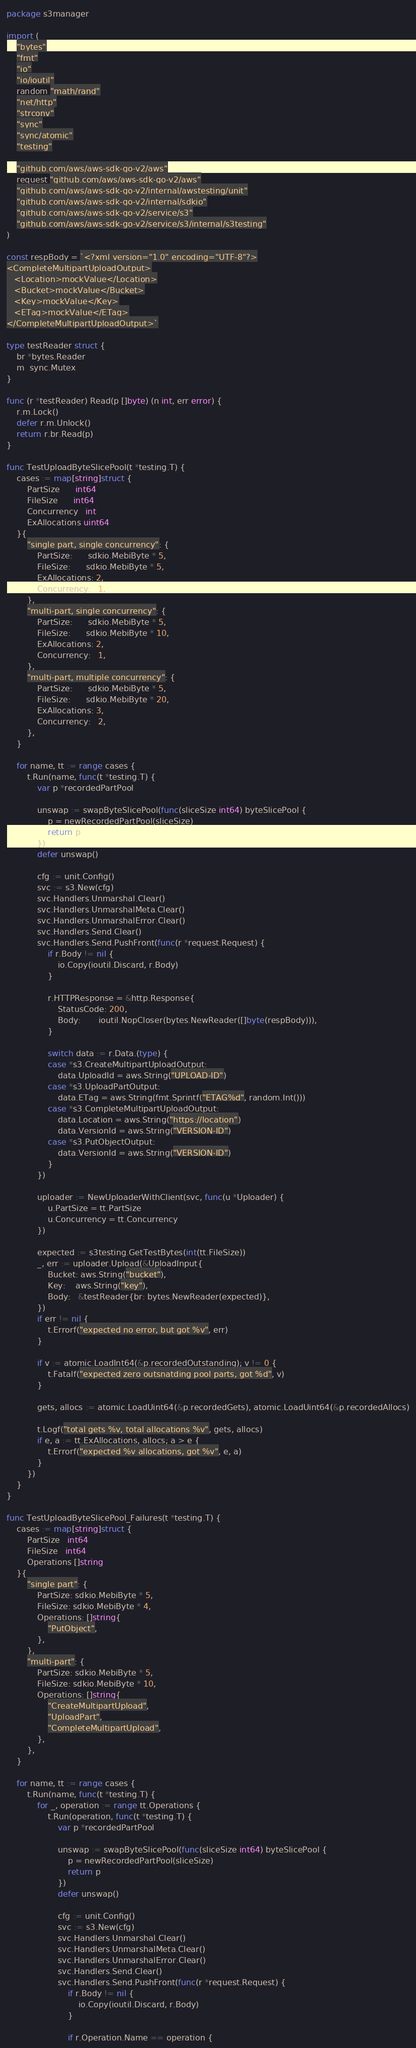Convert code to text. <code><loc_0><loc_0><loc_500><loc_500><_Go_>package s3manager

import (
	"bytes"
	"fmt"
	"io"
	"io/ioutil"
	random "math/rand"
	"net/http"
	"strconv"
	"sync"
	"sync/atomic"
	"testing"

	"github.com/aws/aws-sdk-go-v2/aws"
	request "github.com/aws/aws-sdk-go-v2/aws"
	"github.com/aws/aws-sdk-go-v2/internal/awstesting/unit"
	"github.com/aws/aws-sdk-go-v2/internal/sdkio"
	"github.com/aws/aws-sdk-go-v2/service/s3"
	"github.com/aws/aws-sdk-go-v2/service/s3/internal/s3testing"
)

const respBody = `<?xml version="1.0" encoding="UTF-8"?>
<CompleteMultipartUploadOutput>
   <Location>mockValue</Location>
   <Bucket>mockValue</Bucket>
   <Key>mockValue</Key>
   <ETag>mockValue</ETag>
</CompleteMultipartUploadOutput>`

type testReader struct {
	br *bytes.Reader
	m  sync.Mutex
}

func (r *testReader) Read(p []byte) (n int, err error) {
	r.m.Lock()
	defer r.m.Unlock()
	return r.br.Read(p)
}

func TestUploadByteSlicePool(t *testing.T) {
	cases := map[string]struct {
		PartSize      int64
		FileSize      int64
		Concurrency   int
		ExAllocations uint64
	}{
		"single part, single concurrency": {
			PartSize:      sdkio.MebiByte * 5,
			FileSize:      sdkio.MebiByte * 5,
			ExAllocations: 2,
			Concurrency:   1,
		},
		"multi-part, single concurrency": {
			PartSize:      sdkio.MebiByte * 5,
			FileSize:      sdkio.MebiByte * 10,
			ExAllocations: 2,
			Concurrency:   1,
		},
		"multi-part, multiple concurrency": {
			PartSize:      sdkio.MebiByte * 5,
			FileSize:      sdkio.MebiByte * 20,
			ExAllocations: 3,
			Concurrency:   2,
		},
	}

	for name, tt := range cases {
		t.Run(name, func(t *testing.T) {
			var p *recordedPartPool

			unswap := swapByteSlicePool(func(sliceSize int64) byteSlicePool {
				p = newRecordedPartPool(sliceSize)
				return p
			})
			defer unswap()

			cfg := unit.Config()
			svc := s3.New(cfg)
			svc.Handlers.Unmarshal.Clear()
			svc.Handlers.UnmarshalMeta.Clear()
			svc.Handlers.UnmarshalError.Clear()
			svc.Handlers.Send.Clear()
			svc.Handlers.Send.PushFront(func(r *request.Request) {
				if r.Body != nil {
					io.Copy(ioutil.Discard, r.Body)
				}

				r.HTTPResponse = &http.Response{
					StatusCode: 200,
					Body:       ioutil.NopCloser(bytes.NewReader([]byte(respBody))),
				}

				switch data := r.Data.(type) {
				case *s3.CreateMultipartUploadOutput:
					data.UploadId = aws.String("UPLOAD-ID")
				case *s3.UploadPartOutput:
					data.ETag = aws.String(fmt.Sprintf("ETAG%d", random.Int()))
				case *s3.CompleteMultipartUploadOutput:
					data.Location = aws.String("https://location")
					data.VersionId = aws.String("VERSION-ID")
				case *s3.PutObjectOutput:
					data.VersionId = aws.String("VERSION-ID")
				}
			})

			uploader := NewUploaderWithClient(svc, func(u *Uploader) {
				u.PartSize = tt.PartSize
				u.Concurrency = tt.Concurrency
			})

			expected := s3testing.GetTestBytes(int(tt.FileSize))
			_, err := uploader.Upload(&UploadInput{
				Bucket: aws.String("bucket"),
				Key:    aws.String("key"),
				Body:   &testReader{br: bytes.NewReader(expected)},
			})
			if err != nil {
				t.Errorf("expected no error, but got %v", err)
			}

			if v := atomic.LoadInt64(&p.recordedOutstanding); v != 0 {
				t.Fatalf("expected zero outsnatding pool parts, got %d", v)
			}

			gets, allocs := atomic.LoadUint64(&p.recordedGets), atomic.LoadUint64(&p.recordedAllocs)

			t.Logf("total gets %v, total allocations %v", gets, allocs)
			if e, a := tt.ExAllocations, allocs; a > e {
				t.Errorf("expected %v allocations, got %v", e, a)
			}
		})
	}
}

func TestUploadByteSlicePool_Failures(t *testing.T) {
	cases := map[string]struct {
		PartSize   int64
		FileSize   int64
		Operations []string
	}{
		"single part": {
			PartSize: sdkio.MebiByte * 5,
			FileSize: sdkio.MebiByte * 4,
			Operations: []string{
				"PutObject",
			},
		},
		"multi-part": {
			PartSize: sdkio.MebiByte * 5,
			FileSize: sdkio.MebiByte * 10,
			Operations: []string{
				"CreateMultipartUpload",
				"UploadPart",
				"CompleteMultipartUpload",
			},
		},
	}

	for name, tt := range cases {
		t.Run(name, func(t *testing.T) {
			for _, operation := range tt.Operations {
				t.Run(operation, func(t *testing.T) {
					var p *recordedPartPool

					unswap := swapByteSlicePool(func(sliceSize int64) byteSlicePool {
						p = newRecordedPartPool(sliceSize)
						return p
					})
					defer unswap()

					cfg := unit.Config()
					svc := s3.New(cfg)
					svc.Handlers.Unmarshal.Clear()
					svc.Handlers.UnmarshalMeta.Clear()
					svc.Handlers.UnmarshalError.Clear()
					svc.Handlers.Send.Clear()
					svc.Handlers.Send.PushFront(func(r *request.Request) {
						if r.Body != nil {
							io.Copy(ioutil.Discard, r.Body)
						}

						if r.Operation.Name == operation {</code> 